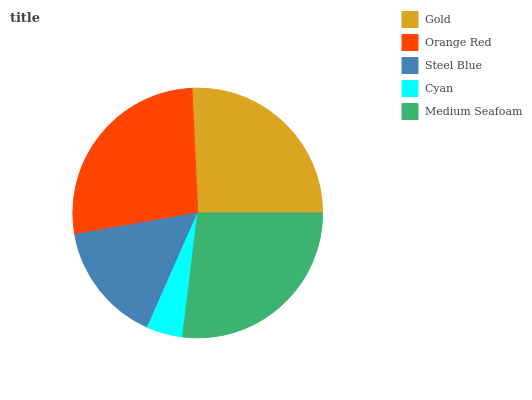Is Cyan the minimum?
Answer yes or no. Yes. Is Orange Red the maximum?
Answer yes or no. Yes. Is Steel Blue the minimum?
Answer yes or no. No. Is Steel Blue the maximum?
Answer yes or no. No. Is Orange Red greater than Steel Blue?
Answer yes or no. Yes. Is Steel Blue less than Orange Red?
Answer yes or no. Yes. Is Steel Blue greater than Orange Red?
Answer yes or no. No. Is Orange Red less than Steel Blue?
Answer yes or no. No. Is Gold the high median?
Answer yes or no. Yes. Is Gold the low median?
Answer yes or no. Yes. Is Steel Blue the high median?
Answer yes or no. No. Is Orange Red the low median?
Answer yes or no. No. 